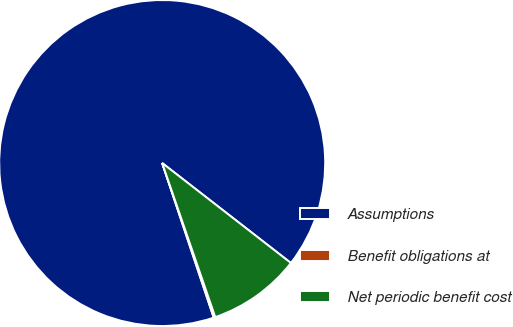Convert chart. <chart><loc_0><loc_0><loc_500><loc_500><pie_chart><fcel>Assumptions<fcel>Benefit obligations at<fcel>Net periodic benefit cost<nl><fcel>90.64%<fcel>0.16%<fcel>9.21%<nl></chart> 